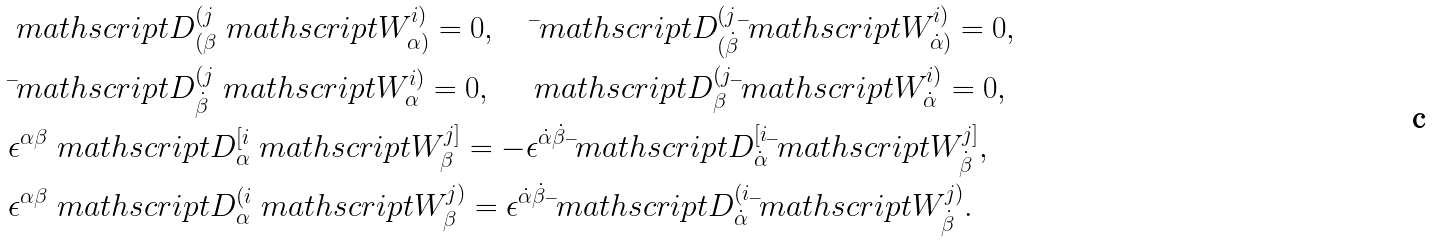<formula> <loc_0><loc_0><loc_500><loc_500>& \ m a t h s c r i p t { D } ^ { ( j } _ { ( \beta } \ m a t h s c r i p t { W } ^ { i ) } _ { \alpha ) } = 0 , \quad \bar { \ } m a t h s c r i p t { D } ^ { ( j } _ { ( \dot { \beta } } \bar { \ } m a t h s c r i p t { W } ^ { i ) } _ { \dot { \alpha } ) } = 0 , \\ & \bar { \ } m a t h s c r i p t { D } ^ { ( j } _ { \dot { \beta } } \ m a t h s c r i p t { W } ^ { i ) } _ { \alpha } = 0 , \quad \ m a t h s c r i p t { D } ^ { ( j } _ { \beta } \bar { \ } m a t h s c r i p t { W } ^ { i ) } _ { \dot { \alpha } } = 0 , \\ & \epsilon ^ { \alpha \beta } \ m a t h s c r i p t { D } _ { \alpha } ^ { [ i } \ m a t h s c r i p t { W } _ { \beta } ^ { j ] } = - \epsilon ^ { \dot { \alpha } \dot { \beta } } \bar { \ } m a t h s c r i p t { D } _ { \dot { \alpha } } ^ { [ i } \bar { \ } m a t h s c r i p t { W } _ { \dot { \beta } } ^ { j ] } , \\ & \epsilon ^ { \alpha \beta } \ m a t h s c r i p t { D } _ { \alpha } ^ { ( i } \ m a t h s c r i p t { W } _ { \beta } ^ { j ) } = \epsilon ^ { \dot { \alpha } \dot { \beta } } \bar { \ } m a t h s c r i p t { D } _ { \dot { \alpha } } ^ { ( i } \bar { \ } m a t h s c r i p t { W } _ { \dot { \beta } } ^ { j ) } .</formula> 